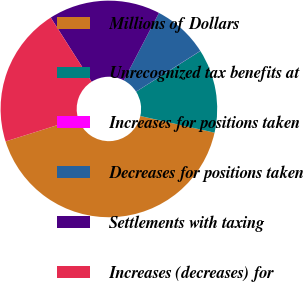<chart> <loc_0><loc_0><loc_500><loc_500><pie_chart><fcel>Millions of Dollars<fcel>Unrecognized tax benefits at<fcel>Increases for positions taken<fcel>Decreases for positions taken<fcel>Settlements with taxing<fcel>Increases (decreases) for<nl><fcel>41.64%<fcel>12.51%<fcel>0.02%<fcel>8.34%<fcel>16.67%<fcel>20.83%<nl></chart> 